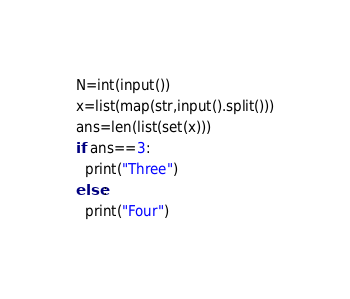Convert code to text. <code><loc_0><loc_0><loc_500><loc_500><_Python_>N=int(input())
x=list(map(str,input().split()))
ans=len(list(set(x)))
if ans==3:
  print("Three")
else:
  print("Four")</code> 